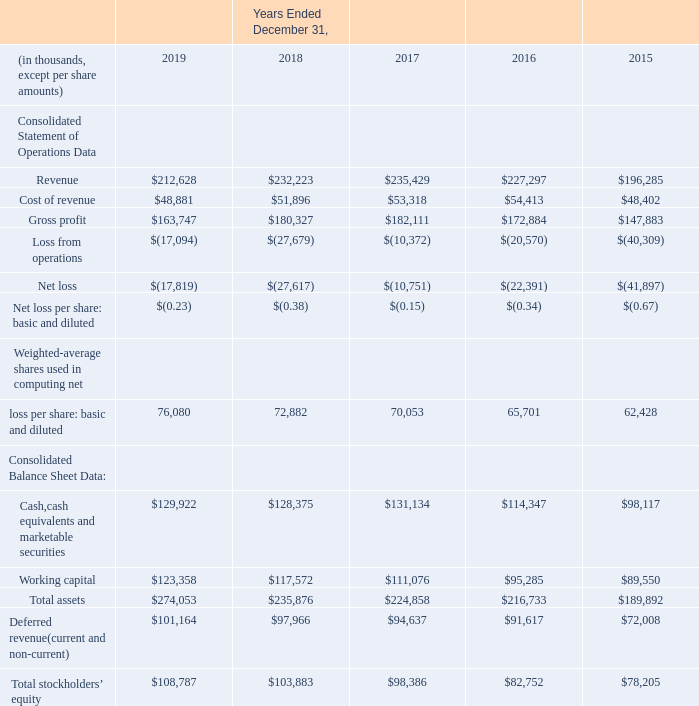Item 6. Selected Financial Data
We have derived the consolidated statement of operations data for the years ended December 31, 2019, 2018 and 2017 and the selected consolidated balance sheet data as of December 31, 2019 and 2018 from our audited consolidated financial statements that are included in this Form 10-K. The following selected consolidated statement of operations data for the years ended December 31, 2016 and 2015 and the selected consolidated balance sheet data as of December 31, 2017, 2016 and 2015 are derived from our audited consolidated financial statements that are not included in this report
Our historical operating results are not necessarily indicative of future operating results, these selected consolidated financial data should be read in conjunction with the consolidated financial statements and accompanying notes in Part II, Item 8, and Management’s Discussion and Analysis of Financial Condition and Results of Operations in Part II, Item 7 included in this report
The amounts as of and for the years ended December 31, 2019 and 2018 have been prepared based on our adoption of Accounting Standards Codification (‘‘ASC’’) No. 606, Contracts with Customers. We elected to adopt this accounting standard on a modified retrospective basis which resulted in the impact of adoption being recorded as of January 1, 2018. The amounts in all other years, other than 2019 and 2018, in the tables below have been prepared on the previously outstanding guidance on revenue recognition. We have disclosed the ASC 606 adoption impact on our revenue recognition in Note 2 of the audited consolidated financial statements included in Part II, Item 8 of this report
The amounts as of and for the years ended December 31, 2019 and 2018 have been prepared based on our adoption of Accounting Standards Codification (‘‘ASC’’) No. 606, Contracts with Customers. We elected to adopt this accounting standard on a modified retrospective basis which resulted in the impact of adoption being recorded as of January 1, 2018. The amounts in all other years, other than 2019 and 2018, in the tables below have been prepared on the previously outstanding guidance on revenue recognition. We have disclosed the ASC 606 adoption impact on our revenue recognition in Note 2 of the audited consolidated financial statements included in Part II, Item 8 of this report
What are the years included in the consolidated statement of operations? 2019, 2018, 2017, 2016, 2015. What is the accounting standards used to prepare the financial statements? Accounting standards codification. What is the total revenue earned by the company in 2019? $212,628. What is the percentage change in revenue between 2018 and 2019?
Answer scale should be: percent. ($212,628-$232,223)/$232,223
Answer: -8.44. What is the percentage change in gross profit between 2018 and 2019?
Answer scale should be: percent. (163,747-180,327)/180,327 
Answer: -9.19. What is the total revenue earned by the company between 2015 to 2019?
Answer scale should be: thousand. 212,628+232,223+235,429+227,297
Answer: 907577. 